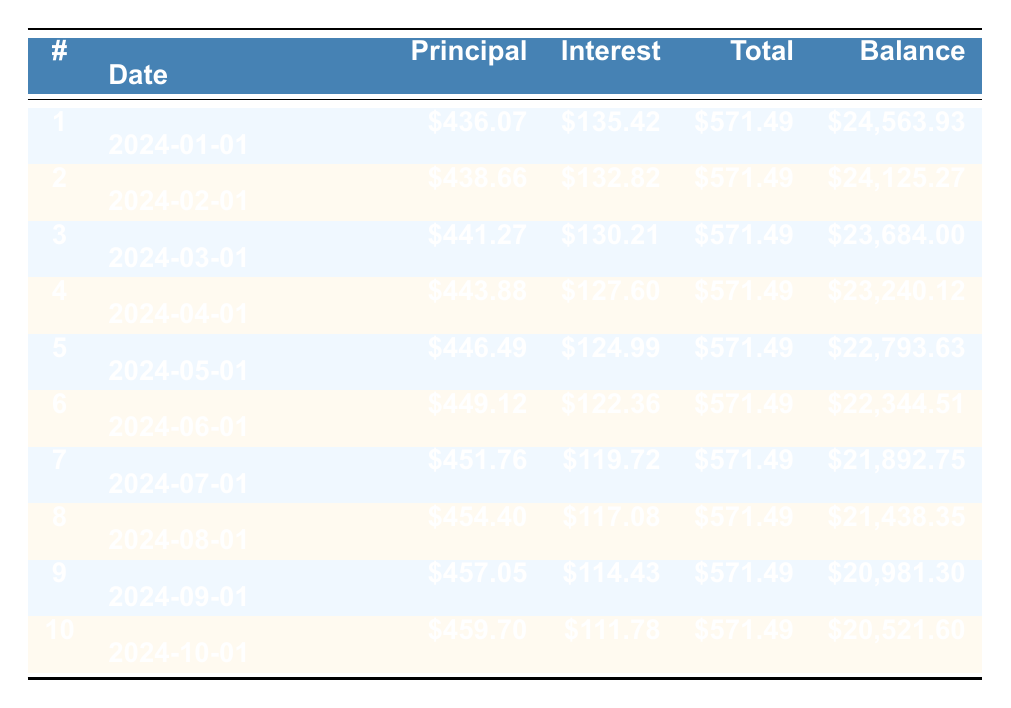What is the total payment for the first month? The total payment for the first month is directly listed in the table under the "Total" column for payment number 1. It is \$571.49.
Answer: 571.49 How much is the remaining balance after the second payment? The remaining balance after the second payment is provided in the "Balance" column for payment number 2. According to the table, it is \$24,125.27.
Answer: 24125.27 What is the total principal payment made in the first three months? The principal payments in the first three months are \$436.07, \$438.66, and \$441.27. Adding them together gives: 436.07 + 438.66 + 441.27 = 1,316.00.
Answer: 1316.00 Is the interest payment for the seventh month lower than \$120? The interest payment for the seventh month is listed as \$119.72, which is indeed lower than \$120. Therefore, this statement is true.
Answer: Yes What is the average principal payment made across the first five months? The principal payments for the first five months are \$436.07, \$438.66, \$441.27, \$443.88, and \$446.49. Summing these gives: 436.07 + 438.66 + 441.27 + 443.88 + 446.49 = 2,206.37. Dividing by 5 to find the average gives 2,206.37 / 5 = 441.27.
Answer: 441.27 How much interest will be paid on the last payment? The interest payment for the last (tenth) payment is explicitly listed in the table under the "Interest" column for payment number 10, which is \$111.78.
Answer: 111.78 What is the change in remaining balance from the first payment to the second payment? The remaining balance after the first payment is \$24,563.93, and after the second payment, it is \$24,125.27. The change can be calculated by subtracting the second balance from the first: 24,563.93 - 24,125.27 = 438.66.
Answer: 438.66 Is the total payment consistent every month? The total payment amount is the same across all months, as indicated in the table; each month shows \$571.49 indicating consistency.
Answer: Yes What is the total amount of interest paid during the first four months? The interest payments for the first four months are \$135.42, \$132.82, \$130.21, and \$127.60. Adding these values: 135.42 + 132.82 + 130.21 + 127.60 = 525.05 gives the total interest paid in this period.
Answer: 525.05 